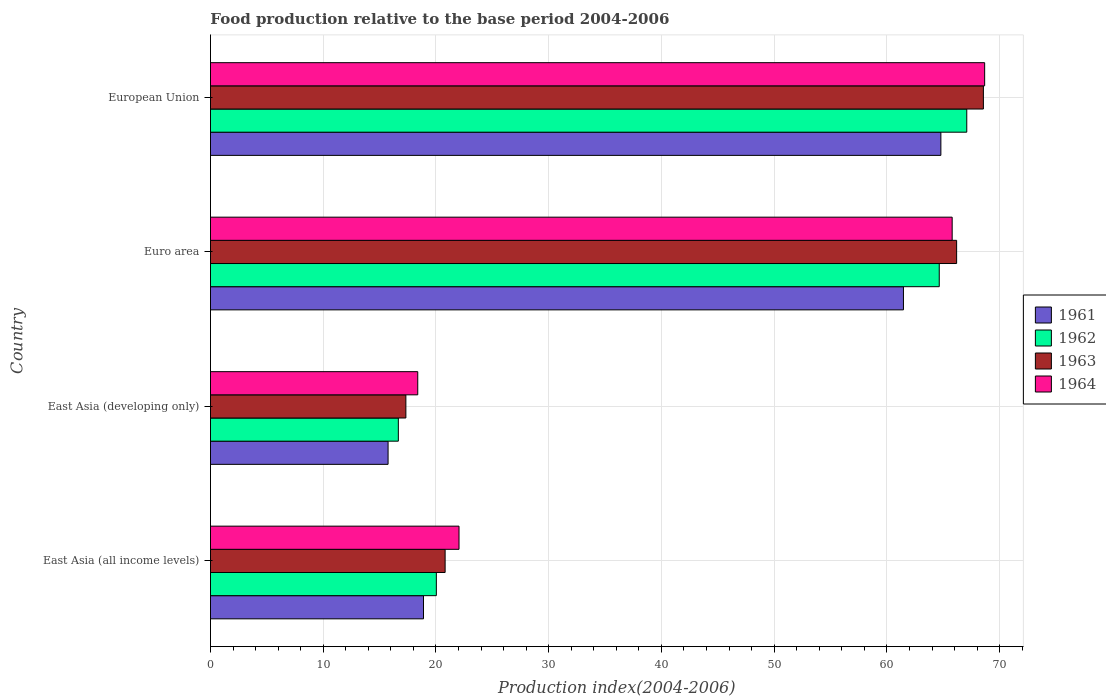How many groups of bars are there?
Your answer should be compact. 4. Are the number of bars per tick equal to the number of legend labels?
Make the answer very short. Yes. Are the number of bars on each tick of the Y-axis equal?
Your answer should be very brief. Yes. How many bars are there on the 3rd tick from the top?
Offer a terse response. 4. How many bars are there on the 2nd tick from the bottom?
Your response must be concise. 4. What is the label of the 3rd group of bars from the top?
Your answer should be very brief. East Asia (developing only). In how many cases, is the number of bars for a given country not equal to the number of legend labels?
Your answer should be compact. 0. What is the food production index in 1964 in East Asia (developing only)?
Give a very brief answer. 18.38. Across all countries, what is the maximum food production index in 1962?
Offer a very short reply. 67.08. Across all countries, what is the minimum food production index in 1961?
Your answer should be compact. 15.75. In which country was the food production index in 1961 maximum?
Your answer should be very brief. European Union. In which country was the food production index in 1964 minimum?
Keep it short and to the point. East Asia (developing only). What is the total food production index in 1964 in the graph?
Give a very brief answer. 174.89. What is the difference between the food production index in 1963 in East Asia (all income levels) and that in East Asia (developing only)?
Provide a short and direct response. 3.48. What is the difference between the food production index in 1962 in East Asia (developing only) and the food production index in 1961 in European Union?
Your response must be concise. -48.12. What is the average food production index in 1964 per country?
Your response must be concise. 43.72. What is the difference between the food production index in 1962 and food production index in 1963 in East Asia (developing only)?
Keep it short and to the point. -0.67. In how many countries, is the food production index in 1963 greater than 12 ?
Provide a succinct answer. 4. What is the ratio of the food production index in 1962 in East Asia (all income levels) to that in East Asia (developing only)?
Ensure brevity in your answer.  1.2. Is the food production index in 1963 in Euro area less than that in European Union?
Your answer should be very brief. Yes. What is the difference between the highest and the second highest food production index in 1961?
Offer a very short reply. 3.32. What is the difference between the highest and the lowest food production index in 1961?
Give a very brief answer. 49.03. What does the 1st bar from the top in Euro area represents?
Provide a succinct answer. 1964. What does the 2nd bar from the bottom in East Asia (all income levels) represents?
Offer a terse response. 1962. How many bars are there?
Provide a succinct answer. 16. Are all the bars in the graph horizontal?
Your answer should be compact. Yes. Where does the legend appear in the graph?
Provide a short and direct response. Center right. How many legend labels are there?
Offer a terse response. 4. What is the title of the graph?
Give a very brief answer. Food production relative to the base period 2004-2006. Does "1982" appear as one of the legend labels in the graph?
Your response must be concise. No. What is the label or title of the X-axis?
Keep it short and to the point. Production index(2004-2006). What is the label or title of the Y-axis?
Offer a very short reply. Country. What is the Production index(2004-2006) in 1961 in East Asia (all income levels)?
Offer a terse response. 18.89. What is the Production index(2004-2006) in 1962 in East Asia (all income levels)?
Ensure brevity in your answer.  20.03. What is the Production index(2004-2006) of 1963 in East Asia (all income levels)?
Provide a succinct answer. 20.81. What is the Production index(2004-2006) in 1964 in East Asia (all income levels)?
Ensure brevity in your answer.  22.05. What is the Production index(2004-2006) in 1961 in East Asia (developing only)?
Your answer should be compact. 15.75. What is the Production index(2004-2006) in 1962 in East Asia (developing only)?
Your answer should be compact. 16.66. What is the Production index(2004-2006) of 1963 in East Asia (developing only)?
Your answer should be very brief. 17.33. What is the Production index(2004-2006) of 1964 in East Asia (developing only)?
Keep it short and to the point. 18.38. What is the Production index(2004-2006) in 1961 in Euro area?
Provide a succinct answer. 61.47. What is the Production index(2004-2006) in 1962 in Euro area?
Your response must be concise. 64.64. What is the Production index(2004-2006) of 1963 in Euro area?
Give a very brief answer. 66.18. What is the Production index(2004-2006) in 1964 in Euro area?
Offer a very short reply. 65.79. What is the Production index(2004-2006) of 1961 in European Union?
Offer a very short reply. 64.79. What is the Production index(2004-2006) in 1962 in European Union?
Make the answer very short. 67.08. What is the Production index(2004-2006) of 1963 in European Union?
Provide a succinct answer. 68.56. What is the Production index(2004-2006) of 1964 in European Union?
Offer a terse response. 68.67. Across all countries, what is the maximum Production index(2004-2006) in 1961?
Provide a succinct answer. 64.79. Across all countries, what is the maximum Production index(2004-2006) in 1962?
Give a very brief answer. 67.08. Across all countries, what is the maximum Production index(2004-2006) in 1963?
Ensure brevity in your answer.  68.56. Across all countries, what is the maximum Production index(2004-2006) of 1964?
Give a very brief answer. 68.67. Across all countries, what is the minimum Production index(2004-2006) in 1961?
Offer a very short reply. 15.75. Across all countries, what is the minimum Production index(2004-2006) of 1962?
Offer a very short reply. 16.66. Across all countries, what is the minimum Production index(2004-2006) of 1963?
Give a very brief answer. 17.33. Across all countries, what is the minimum Production index(2004-2006) of 1964?
Your response must be concise. 18.38. What is the total Production index(2004-2006) in 1961 in the graph?
Keep it short and to the point. 160.9. What is the total Production index(2004-2006) in 1962 in the graph?
Provide a short and direct response. 168.42. What is the total Production index(2004-2006) of 1963 in the graph?
Your answer should be compact. 172.88. What is the total Production index(2004-2006) of 1964 in the graph?
Give a very brief answer. 174.89. What is the difference between the Production index(2004-2006) in 1961 in East Asia (all income levels) and that in East Asia (developing only)?
Your answer should be very brief. 3.14. What is the difference between the Production index(2004-2006) in 1962 in East Asia (all income levels) and that in East Asia (developing only)?
Your response must be concise. 3.37. What is the difference between the Production index(2004-2006) of 1963 in East Asia (all income levels) and that in East Asia (developing only)?
Offer a very short reply. 3.48. What is the difference between the Production index(2004-2006) of 1964 in East Asia (all income levels) and that in East Asia (developing only)?
Make the answer very short. 3.66. What is the difference between the Production index(2004-2006) of 1961 in East Asia (all income levels) and that in Euro area?
Keep it short and to the point. -42.57. What is the difference between the Production index(2004-2006) in 1962 in East Asia (all income levels) and that in Euro area?
Ensure brevity in your answer.  -44.61. What is the difference between the Production index(2004-2006) of 1963 in East Asia (all income levels) and that in Euro area?
Keep it short and to the point. -45.37. What is the difference between the Production index(2004-2006) of 1964 in East Asia (all income levels) and that in Euro area?
Offer a very short reply. -43.74. What is the difference between the Production index(2004-2006) of 1961 in East Asia (all income levels) and that in European Union?
Offer a very short reply. -45.89. What is the difference between the Production index(2004-2006) in 1962 in East Asia (all income levels) and that in European Union?
Ensure brevity in your answer.  -47.05. What is the difference between the Production index(2004-2006) of 1963 in East Asia (all income levels) and that in European Union?
Your answer should be very brief. -47.74. What is the difference between the Production index(2004-2006) of 1964 in East Asia (all income levels) and that in European Union?
Your response must be concise. -46.62. What is the difference between the Production index(2004-2006) of 1961 in East Asia (developing only) and that in Euro area?
Your answer should be compact. -45.71. What is the difference between the Production index(2004-2006) of 1962 in East Asia (developing only) and that in Euro area?
Your answer should be very brief. -47.98. What is the difference between the Production index(2004-2006) in 1963 in East Asia (developing only) and that in Euro area?
Provide a short and direct response. -48.85. What is the difference between the Production index(2004-2006) of 1964 in East Asia (developing only) and that in Euro area?
Provide a short and direct response. -47.4. What is the difference between the Production index(2004-2006) in 1961 in East Asia (developing only) and that in European Union?
Offer a very short reply. -49.03. What is the difference between the Production index(2004-2006) of 1962 in East Asia (developing only) and that in European Union?
Give a very brief answer. -50.42. What is the difference between the Production index(2004-2006) in 1963 in East Asia (developing only) and that in European Union?
Offer a very short reply. -51.22. What is the difference between the Production index(2004-2006) in 1964 in East Asia (developing only) and that in European Union?
Give a very brief answer. -50.28. What is the difference between the Production index(2004-2006) in 1961 in Euro area and that in European Union?
Offer a terse response. -3.32. What is the difference between the Production index(2004-2006) in 1962 in Euro area and that in European Union?
Make the answer very short. -2.44. What is the difference between the Production index(2004-2006) in 1963 in Euro area and that in European Union?
Offer a very short reply. -2.38. What is the difference between the Production index(2004-2006) of 1964 in Euro area and that in European Union?
Provide a short and direct response. -2.88. What is the difference between the Production index(2004-2006) of 1961 in East Asia (all income levels) and the Production index(2004-2006) of 1962 in East Asia (developing only)?
Offer a very short reply. 2.23. What is the difference between the Production index(2004-2006) in 1961 in East Asia (all income levels) and the Production index(2004-2006) in 1963 in East Asia (developing only)?
Make the answer very short. 1.56. What is the difference between the Production index(2004-2006) of 1961 in East Asia (all income levels) and the Production index(2004-2006) of 1964 in East Asia (developing only)?
Provide a succinct answer. 0.51. What is the difference between the Production index(2004-2006) in 1962 in East Asia (all income levels) and the Production index(2004-2006) in 1963 in East Asia (developing only)?
Provide a short and direct response. 2.7. What is the difference between the Production index(2004-2006) in 1962 in East Asia (all income levels) and the Production index(2004-2006) in 1964 in East Asia (developing only)?
Offer a terse response. 1.65. What is the difference between the Production index(2004-2006) in 1963 in East Asia (all income levels) and the Production index(2004-2006) in 1964 in East Asia (developing only)?
Offer a very short reply. 2.43. What is the difference between the Production index(2004-2006) in 1961 in East Asia (all income levels) and the Production index(2004-2006) in 1962 in Euro area?
Provide a succinct answer. -45.75. What is the difference between the Production index(2004-2006) in 1961 in East Asia (all income levels) and the Production index(2004-2006) in 1963 in Euro area?
Give a very brief answer. -47.29. What is the difference between the Production index(2004-2006) in 1961 in East Asia (all income levels) and the Production index(2004-2006) in 1964 in Euro area?
Make the answer very short. -46.89. What is the difference between the Production index(2004-2006) in 1962 in East Asia (all income levels) and the Production index(2004-2006) in 1963 in Euro area?
Your answer should be very brief. -46.15. What is the difference between the Production index(2004-2006) of 1962 in East Asia (all income levels) and the Production index(2004-2006) of 1964 in Euro area?
Keep it short and to the point. -45.75. What is the difference between the Production index(2004-2006) of 1963 in East Asia (all income levels) and the Production index(2004-2006) of 1964 in Euro area?
Your answer should be compact. -44.97. What is the difference between the Production index(2004-2006) of 1961 in East Asia (all income levels) and the Production index(2004-2006) of 1962 in European Union?
Ensure brevity in your answer.  -48.19. What is the difference between the Production index(2004-2006) of 1961 in East Asia (all income levels) and the Production index(2004-2006) of 1963 in European Union?
Keep it short and to the point. -49.66. What is the difference between the Production index(2004-2006) in 1961 in East Asia (all income levels) and the Production index(2004-2006) in 1964 in European Union?
Your answer should be very brief. -49.77. What is the difference between the Production index(2004-2006) in 1962 in East Asia (all income levels) and the Production index(2004-2006) in 1963 in European Union?
Offer a very short reply. -48.52. What is the difference between the Production index(2004-2006) of 1962 in East Asia (all income levels) and the Production index(2004-2006) of 1964 in European Union?
Give a very brief answer. -48.63. What is the difference between the Production index(2004-2006) of 1963 in East Asia (all income levels) and the Production index(2004-2006) of 1964 in European Union?
Your answer should be very brief. -47.86. What is the difference between the Production index(2004-2006) of 1961 in East Asia (developing only) and the Production index(2004-2006) of 1962 in Euro area?
Provide a succinct answer. -48.89. What is the difference between the Production index(2004-2006) in 1961 in East Asia (developing only) and the Production index(2004-2006) in 1963 in Euro area?
Your response must be concise. -50.43. What is the difference between the Production index(2004-2006) in 1961 in East Asia (developing only) and the Production index(2004-2006) in 1964 in Euro area?
Give a very brief answer. -50.03. What is the difference between the Production index(2004-2006) in 1962 in East Asia (developing only) and the Production index(2004-2006) in 1963 in Euro area?
Make the answer very short. -49.52. What is the difference between the Production index(2004-2006) in 1962 in East Asia (developing only) and the Production index(2004-2006) in 1964 in Euro area?
Provide a short and direct response. -49.12. What is the difference between the Production index(2004-2006) in 1963 in East Asia (developing only) and the Production index(2004-2006) in 1964 in Euro area?
Keep it short and to the point. -48.46. What is the difference between the Production index(2004-2006) of 1961 in East Asia (developing only) and the Production index(2004-2006) of 1962 in European Union?
Your response must be concise. -51.33. What is the difference between the Production index(2004-2006) of 1961 in East Asia (developing only) and the Production index(2004-2006) of 1963 in European Union?
Your answer should be compact. -52.8. What is the difference between the Production index(2004-2006) of 1961 in East Asia (developing only) and the Production index(2004-2006) of 1964 in European Union?
Ensure brevity in your answer.  -52.92. What is the difference between the Production index(2004-2006) of 1962 in East Asia (developing only) and the Production index(2004-2006) of 1963 in European Union?
Keep it short and to the point. -51.89. What is the difference between the Production index(2004-2006) of 1962 in East Asia (developing only) and the Production index(2004-2006) of 1964 in European Union?
Keep it short and to the point. -52.01. What is the difference between the Production index(2004-2006) of 1963 in East Asia (developing only) and the Production index(2004-2006) of 1964 in European Union?
Make the answer very short. -51.34. What is the difference between the Production index(2004-2006) of 1961 in Euro area and the Production index(2004-2006) of 1962 in European Union?
Offer a terse response. -5.62. What is the difference between the Production index(2004-2006) in 1961 in Euro area and the Production index(2004-2006) in 1963 in European Union?
Provide a short and direct response. -7.09. What is the difference between the Production index(2004-2006) of 1961 in Euro area and the Production index(2004-2006) of 1964 in European Union?
Ensure brevity in your answer.  -7.2. What is the difference between the Production index(2004-2006) in 1962 in Euro area and the Production index(2004-2006) in 1963 in European Union?
Ensure brevity in your answer.  -3.92. What is the difference between the Production index(2004-2006) in 1962 in Euro area and the Production index(2004-2006) in 1964 in European Union?
Keep it short and to the point. -4.03. What is the difference between the Production index(2004-2006) of 1963 in Euro area and the Production index(2004-2006) of 1964 in European Union?
Offer a terse response. -2.49. What is the average Production index(2004-2006) of 1961 per country?
Ensure brevity in your answer.  40.22. What is the average Production index(2004-2006) of 1962 per country?
Ensure brevity in your answer.  42.11. What is the average Production index(2004-2006) of 1963 per country?
Keep it short and to the point. 43.22. What is the average Production index(2004-2006) of 1964 per country?
Provide a succinct answer. 43.72. What is the difference between the Production index(2004-2006) in 1961 and Production index(2004-2006) in 1962 in East Asia (all income levels)?
Provide a short and direct response. -1.14. What is the difference between the Production index(2004-2006) of 1961 and Production index(2004-2006) of 1963 in East Asia (all income levels)?
Your response must be concise. -1.92. What is the difference between the Production index(2004-2006) of 1961 and Production index(2004-2006) of 1964 in East Asia (all income levels)?
Keep it short and to the point. -3.15. What is the difference between the Production index(2004-2006) in 1962 and Production index(2004-2006) in 1963 in East Asia (all income levels)?
Your response must be concise. -0.78. What is the difference between the Production index(2004-2006) of 1962 and Production index(2004-2006) of 1964 in East Asia (all income levels)?
Your answer should be compact. -2.01. What is the difference between the Production index(2004-2006) of 1963 and Production index(2004-2006) of 1964 in East Asia (all income levels)?
Your answer should be compact. -1.23. What is the difference between the Production index(2004-2006) in 1961 and Production index(2004-2006) in 1962 in East Asia (developing only)?
Keep it short and to the point. -0.91. What is the difference between the Production index(2004-2006) in 1961 and Production index(2004-2006) in 1963 in East Asia (developing only)?
Provide a succinct answer. -1.58. What is the difference between the Production index(2004-2006) of 1961 and Production index(2004-2006) of 1964 in East Asia (developing only)?
Provide a succinct answer. -2.63. What is the difference between the Production index(2004-2006) of 1962 and Production index(2004-2006) of 1963 in East Asia (developing only)?
Your answer should be very brief. -0.67. What is the difference between the Production index(2004-2006) in 1962 and Production index(2004-2006) in 1964 in East Asia (developing only)?
Your answer should be compact. -1.72. What is the difference between the Production index(2004-2006) of 1963 and Production index(2004-2006) of 1964 in East Asia (developing only)?
Ensure brevity in your answer.  -1.05. What is the difference between the Production index(2004-2006) of 1961 and Production index(2004-2006) of 1962 in Euro area?
Your response must be concise. -3.17. What is the difference between the Production index(2004-2006) in 1961 and Production index(2004-2006) in 1963 in Euro area?
Provide a short and direct response. -4.72. What is the difference between the Production index(2004-2006) in 1961 and Production index(2004-2006) in 1964 in Euro area?
Ensure brevity in your answer.  -4.32. What is the difference between the Production index(2004-2006) of 1962 and Production index(2004-2006) of 1963 in Euro area?
Give a very brief answer. -1.54. What is the difference between the Production index(2004-2006) in 1962 and Production index(2004-2006) in 1964 in Euro area?
Give a very brief answer. -1.15. What is the difference between the Production index(2004-2006) in 1963 and Production index(2004-2006) in 1964 in Euro area?
Ensure brevity in your answer.  0.39. What is the difference between the Production index(2004-2006) in 1961 and Production index(2004-2006) in 1962 in European Union?
Your response must be concise. -2.3. What is the difference between the Production index(2004-2006) in 1961 and Production index(2004-2006) in 1963 in European Union?
Ensure brevity in your answer.  -3.77. What is the difference between the Production index(2004-2006) of 1961 and Production index(2004-2006) of 1964 in European Union?
Make the answer very short. -3.88. What is the difference between the Production index(2004-2006) of 1962 and Production index(2004-2006) of 1963 in European Union?
Provide a short and direct response. -1.47. What is the difference between the Production index(2004-2006) of 1962 and Production index(2004-2006) of 1964 in European Union?
Provide a short and direct response. -1.59. What is the difference between the Production index(2004-2006) of 1963 and Production index(2004-2006) of 1964 in European Union?
Your answer should be very brief. -0.11. What is the ratio of the Production index(2004-2006) of 1961 in East Asia (all income levels) to that in East Asia (developing only)?
Make the answer very short. 1.2. What is the ratio of the Production index(2004-2006) in 1962 in East Asia (all income levels) to that in East Asia (developing only)?
Keep it short and to the point. 1.2. What is the ratio of the Production index(2004-2006) of 1963 in East Asia (all income levels) to that in East Asia (developing only)?
Ensure brevity in your answer.  1.2. What is the ratio of the Production index(2004-2006) in 1964 in East Asia (all income levels) to that in East Asia (developing only)?
Offer a very short reply. 1.2. What is the ratio of the Production index(2004-2006) in 1961 in East Asia (all income levels) to that in Euro area?
Ensure brevity in your answer.  0.31. What is the ratio of the Production index(2004-2006) of 1962 in East Asia (all income levels) to that in Euro area?
Ensure brevity in your answer.  0.31. What is the ratio of the Production index(2004-2006) in 1963 in East Asia (all income levels) to that in Euro area?
Provide a short and direct response. 0.31. What is the ratio of the Production index(2004-2006) of 1964 in East Asia (all income levels) to that in Euro area?
Give a very brief answer. 0.34. What is the ratio of the Production index(2004-2006) of 1961 in East Asia (all income levels) to that in European Union?
Your response must be concise. 0.29. What is the ratio of the Production index(2004-2006) of 1962 in East Asia (all income levels) to that in European Union?
Your answer should be compact. 0.3. What is the ratio of the Production index(2004-2006) of 1963 in East Asia (all income levels) to that in European Union?
Offer a very short reply. 0.3. What is the ratio of the Production index(2004-2006) in 1964 in East Asia (all income levels) to that in European Union?
Provide a short and direct response. 0.32. What is the ratio of the Production index(2004-2006) in 1961 in East Asia (developing only) to that in Euro area?
Make the answer very short. 0.26. What is the ratio of the Production index(2004-2006) in 1962 in East Asia (developing only) to that in Euro area?
Keep it short and to the point. 0.26. What is the ratio of the Production index(2004-2006) in 1963 in East Asia (developing only) to that in Euro area?
Offer a terse response. 0.26. What is the ratio of the Production index(2004-2006) in 1964 in East Asia (developing only) to that in Euro area?
Provide a short and direct response. 0.28. What is the ratio of the Production index(2004-2006) in 1961 in East Asia (developing only) to that in European Union?
Ensure brevity in your answer.  0.24. What is the ratio of the Production index(2004-2006) of 1962 in East Asia (developing only) to that in European Union?
Keep it short and to the point. 0.25. What is the ratio of the Production index(2004-2006) in 1963 in East Asia (developing only) to that in European Union?
Offer a terse response. 0.25. What is the ratio of the Production index(2004-2006) of 1964 in East Asia (developing only) to that in European Union?
Offer a terse response. 0.27. What is the ratio of the Production index(2004-2006) of 1961 in Euro area to that in European Union?
Provide a succinct answer. 0.95. What is the ratio of the Production index(2004-2006) in 1962 in Euro area to that in European Union?
Provide a short and direct response. 0.96. What is the ratio of the Production index(2004-2006) of 1963 in Euro area to that in European Union?
Offer a very short reply. 0.97. What is the ratio of the Production index(2004-2006) in 1964 in Euro area to that in European Union?
Provide a succinct answer. 0.96. What is the difference between the highest and the second highest Production index(2004-2006) of 1961?
Give a very brief answer. 3.32. What is the difference between the highest and the second highest Production index(2004-2006) of 1962?
Your answer should be compact. 2.44. What is the difference between the highest and the second highest Production index(2004-2006) in 1963?
Offer a very short reply. 2.38. What is the difference between the highest and the second highest Production index(2004-2006) of 1964?
Offer a terse response. 2.88. What is the difference between the highest and the lowest Production index(2004-2006) in 1961?
Keep it short and to the point. 49.03. What is the difference between the highest and the lowest Production index(2004-2006) in 1962?
Provide a succinct answer. 50.42. What is the difference between the highest and the lowest Production index(2004-2006) in 1963?
Make the answer very short. 51.22. What is the difference between the highest and the lowest Production index(2004-2006) of 1964?
Provide a succinct answer. 50.28. 